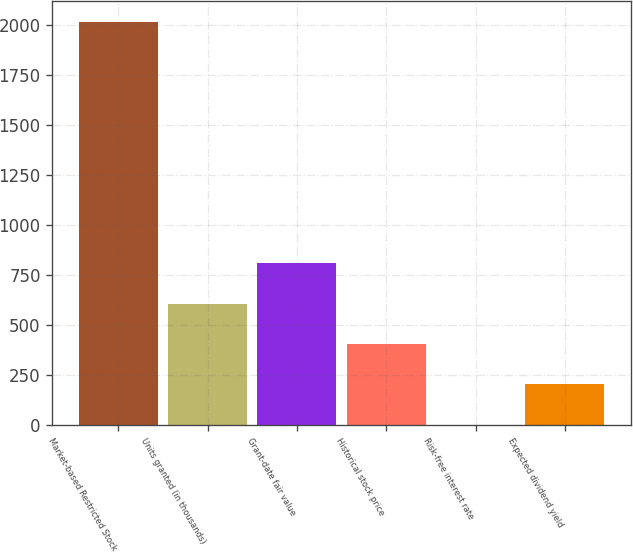<chart> <loc_0><loc_0><loc_500><loc_500><bar_chart><fcel>Market-based Restricted Stock<fcel>Units granted (in thousands)<fcel>Grant-date fair value<fcel>Historical stock price<fcel>Risk-free interest rate<fcel>Expected dividend yield<nl><fcel>2017<fcel>606.22<fcel>807.76<fcel>404.68<fcel>1.6<fcel>203.14<nl></chart> 